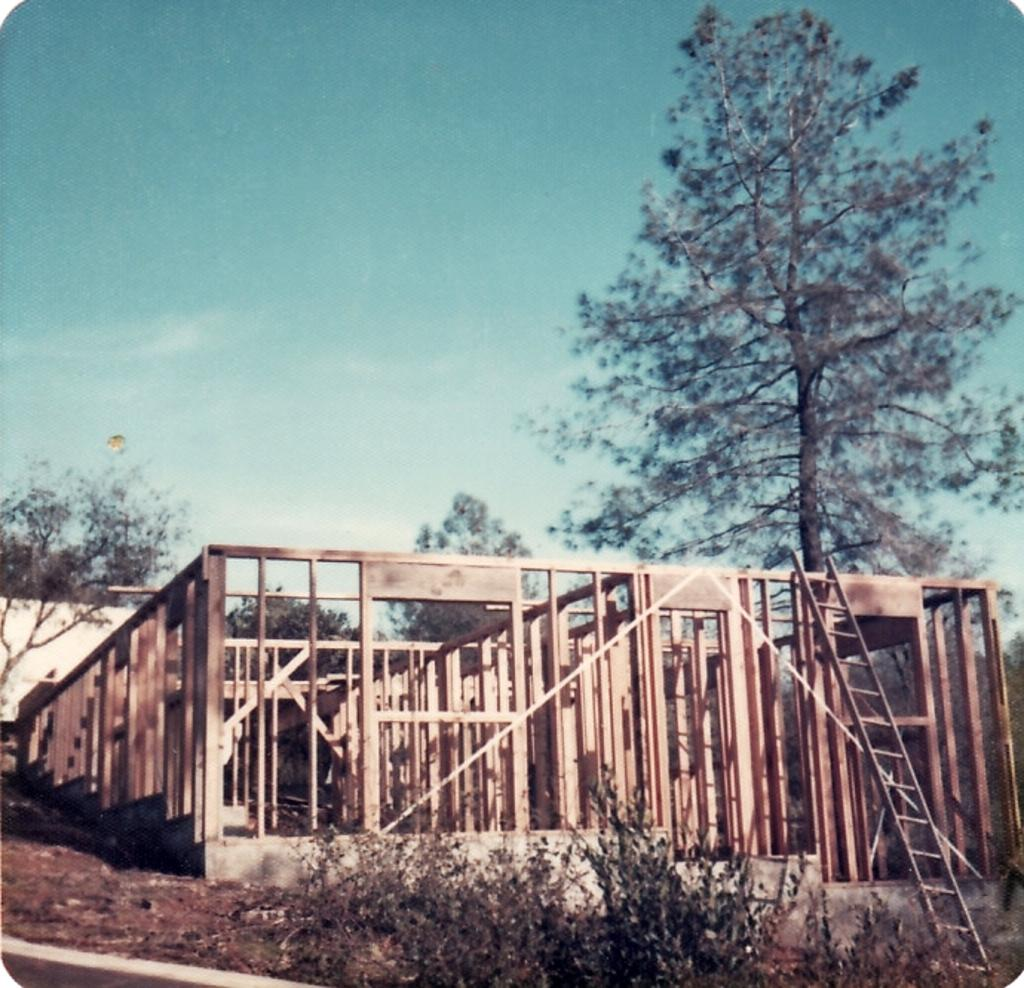What objects made of wood can be seen in the image? There are wooden sticks in the image. What type of natural elements are present in the image? There are trees and small plants in the image. What is the purpose of the ladder in the image? The ladder's purpose is not specified in the image, but it could be used for reaching higher areas. What is the color of the wall in the image? The wall in the image is white in color. What can be seen in the sky in the image? The sky is blue and white in color in the image. Can you tell me how many animals from the zoo are visible in the image? There are no animals from the zoo present in the image. What type of arch can be seen in the image? There is no arch present in the image. 